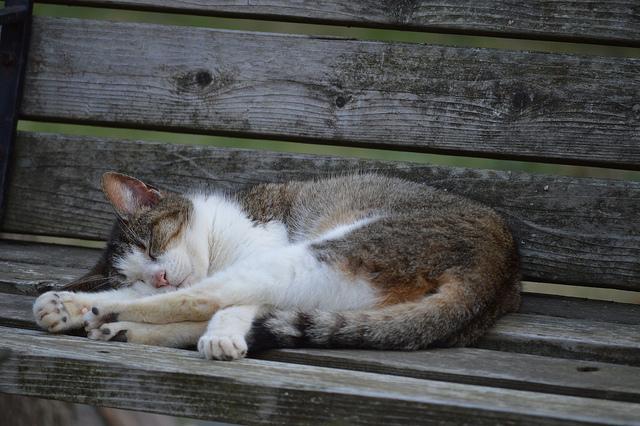How old is the cat?
Answer briefly. 7. What is the cat looking at?
Be succinct. Nothing. What is the cat laying on?
Short answer required. Bench. Is the cat sleeping?
Give a very brief answer. Yes. What is the cat doing?
Write a very short answer. Sleeping. Is the cat a stray?
Answer briefly. No. What color is the cat?
Write a very short answer. Brown and white. 